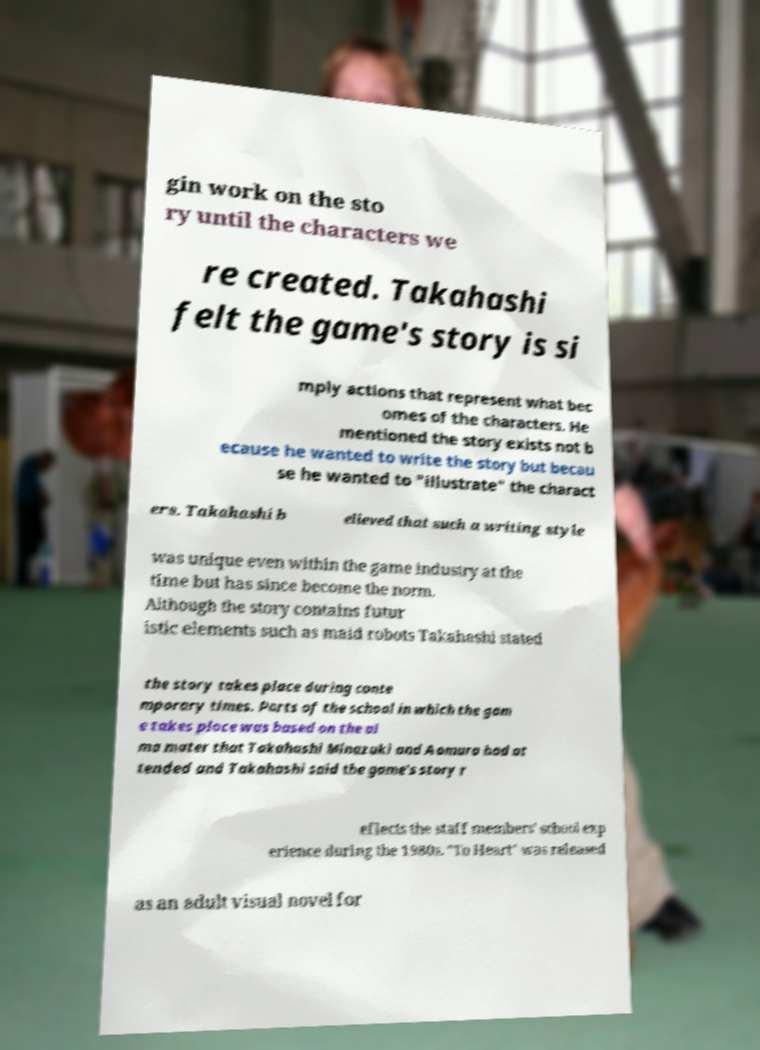Please read and relay the text visible in this image. What does it say? gin work on the sto ry until the characters we re created. Takahashi felt the game's story is si mply actions that represent what bec omes of the characters. He mentioned the story exists not b ecause he wanted to write the story but becau se he wanted to "illustrate" the charact ers. Takahashi b elieved that such a writing style was unique even within the game industry at the time but has since become the norm. Although the story contains futur istic elements such as maid robots Takahashi stated the story takes place during conte mporary times. Parts of the school in which the gam e takes place was based on the al ma mater that Takahashi Minazuki and Aomura had at tended and Takahashi said the game's story r eflects the staff members' school exp erience during the 1980s. "To Heart" was released as an adult visual novel for 